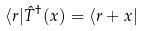Convert formula to latex. <formula><loc_0><loc_0><loc_500><loc_500>\langle r | \hat { T } ^ { \dagger } ( x ) = \langle r + x |</formula> 